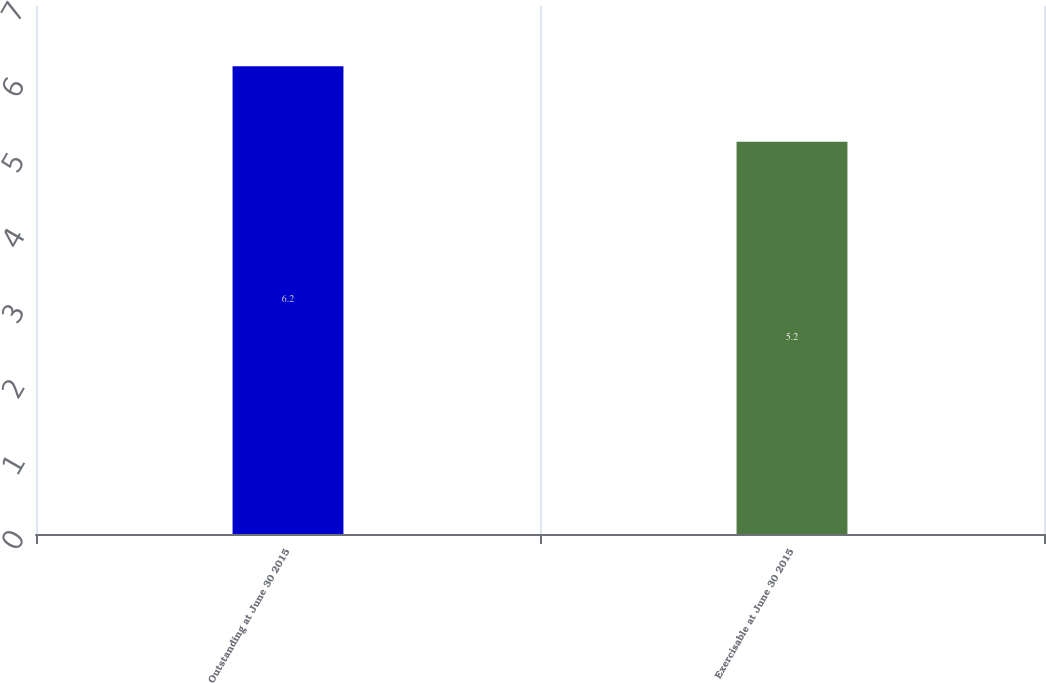Convert chart. <chart><loc_0><loc_0><loc_500><loc_500><bar_chart><fcel>Outstanding at June 30 2015<fcel>Exercisable at June 30 2015<nl><fcel>6.2<fcel>5.2<nl></chart> 